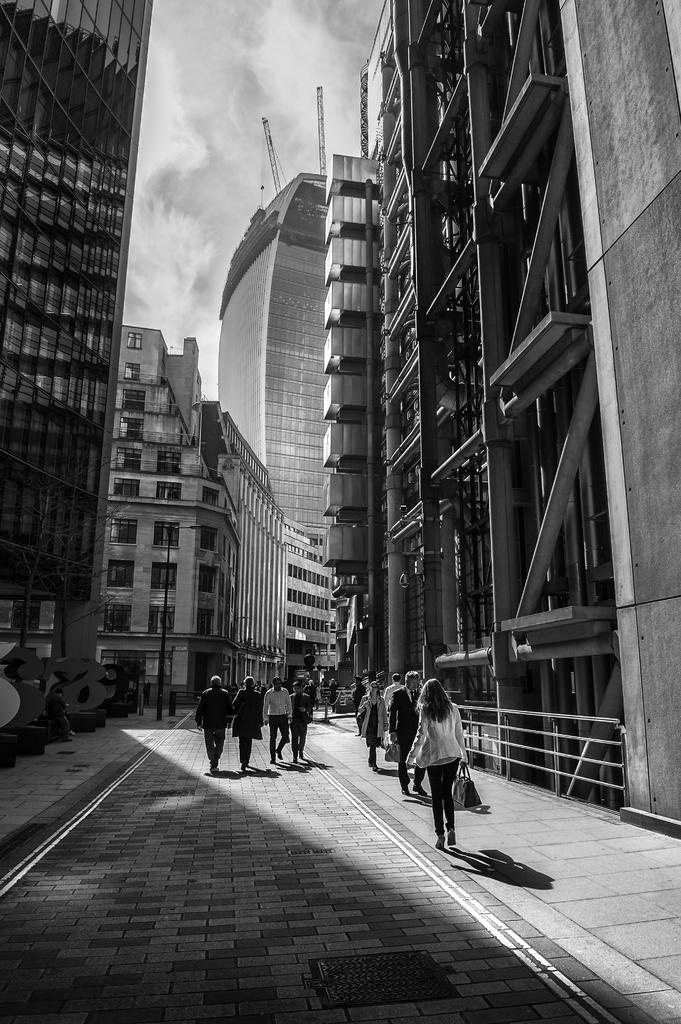How many people are in the image? There is a group of people in the image. What are the people doing in the image? The people are walking on the road. What can be seen in the image besides the people? There is a fence, a pole, buildings with windows, and some objects in the image. What is visible in the background of the image? The sky is visible in the background of the image. Can you see a star flying over the buildings in the image? There is no star visible in the image; only the sky is visible in the background. 